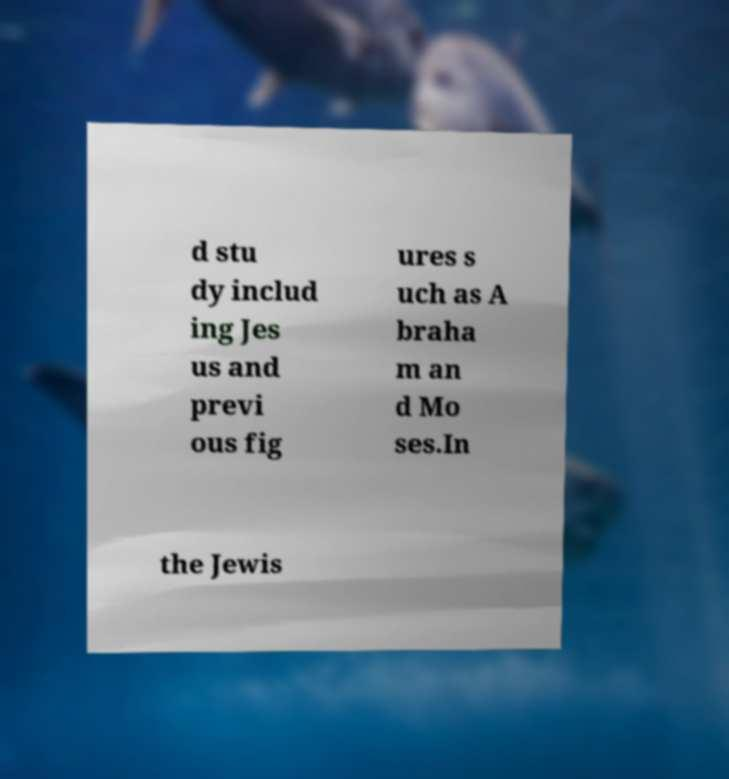There's text embedded in this image that I need extracted. Can you transcribe it verbatim? d stu dy includ ing Jes us and previ ous fig ures s uch as A braha m an d Mo ses.In the Jewis 